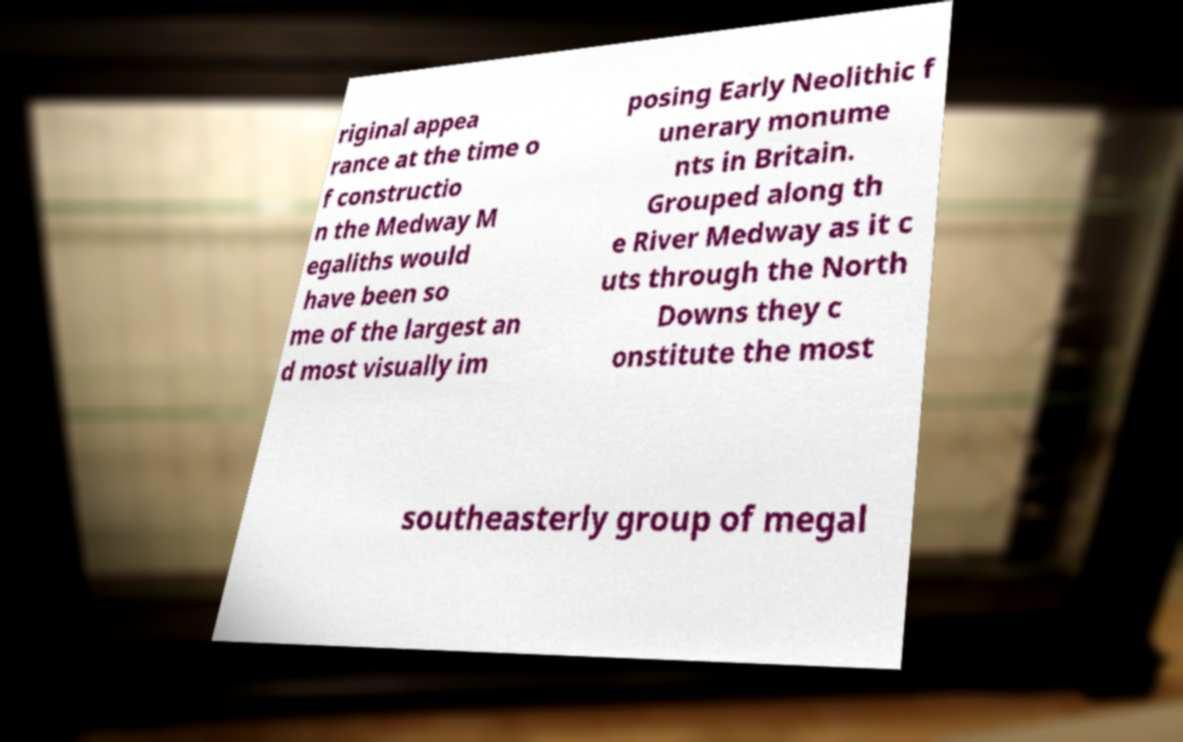What messages or text are displayed in this image? I need them in a readable, typed format. riginal appea rance at the time o f constructio n the Medway M egaliths would have been so me of the largest an d most visually im posing Early Neolithic f unerary monume nts in Britain. Grouped along th e River Medway as it c uts through the North Downs they c onstitute the most southeasterly group of megal 